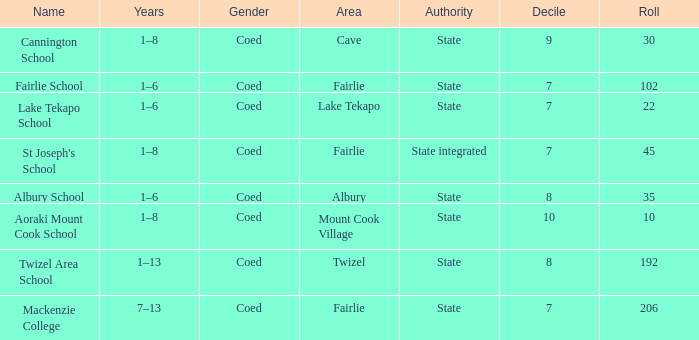What is the total Decile that has a state authority, fairlie area and roll smarter than 206? 1.0. Parse the table in full. {'header': ['Name', 'Years', 'Gender', 'Area', 'Authority', 'Decile', 'Roll'], 'rows': [['Cannington School', '1–8', 'Coed', 'Cave', 'State', '9', '30'], ['Fairlie School', '1–6', 'Coed', 'Fairlie', 'State', '7', '102'], ['Lake Tekapo School', '1–6', 'Coed', 'Lake Tekapo', 'State', '7', '22'], ["St Joseph's School", '1–8', 'Coed', 'Fairlie', 'State integrated', '7', '45'], ['Albury School', '1–6', 'Coed', 'Albury', 'State', '8', '35'], ['Aoraki Mount Cook School', '1–8', 'Coed', 'Mount Cook Village', 'State', '10', '10'], ['Twizel Area School', '1–13', 'Coed', 'Twizel', 'State', '8', '192'], ['Mackenzie College', '7–13', 'Coed', 'Fairlie', 'State', '7', '206']]} 